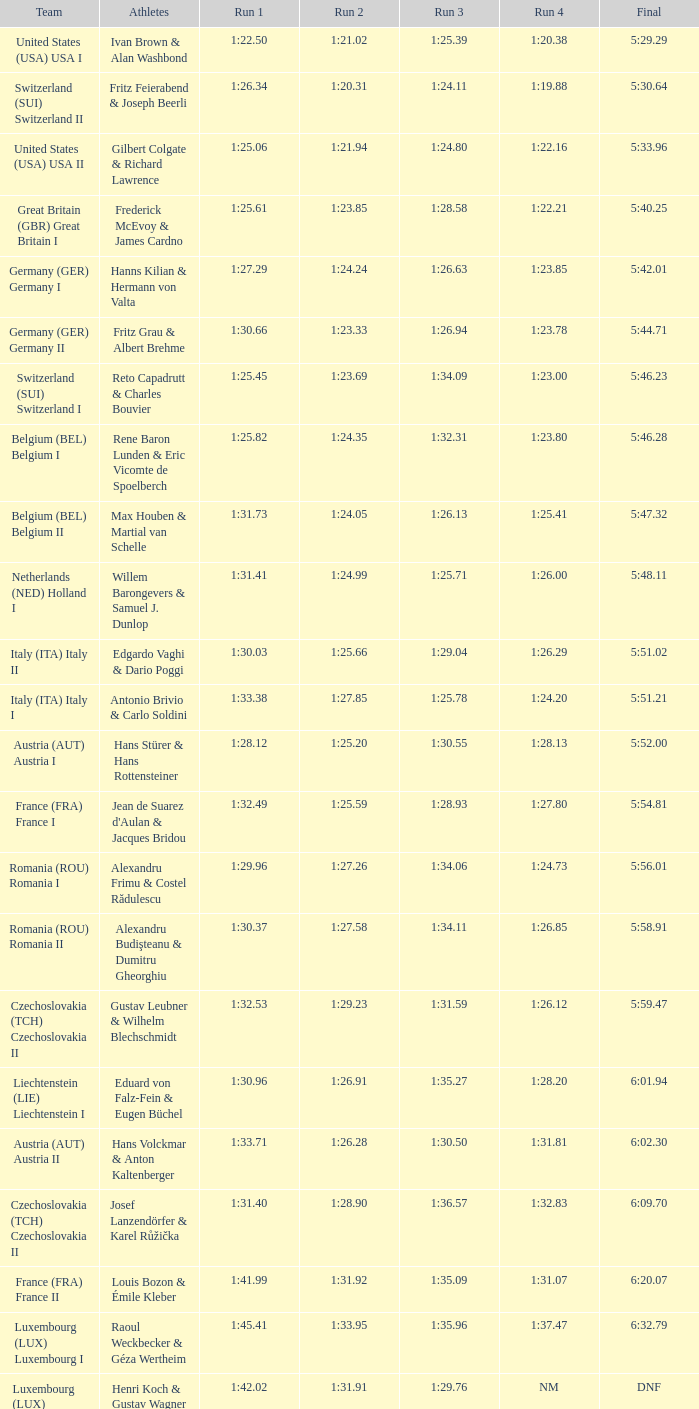Which Run 4 has a Run 1 of 1:25.82? 1:23.80. 